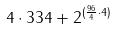Convert formula to latex. <formula><loc_0><loc_0><loc_500><loc_500>4 \cdot 3 3 4 + 2 ^ { ( \frac { 9 6 } { 4 } \cdot 4 ) }</formula> 